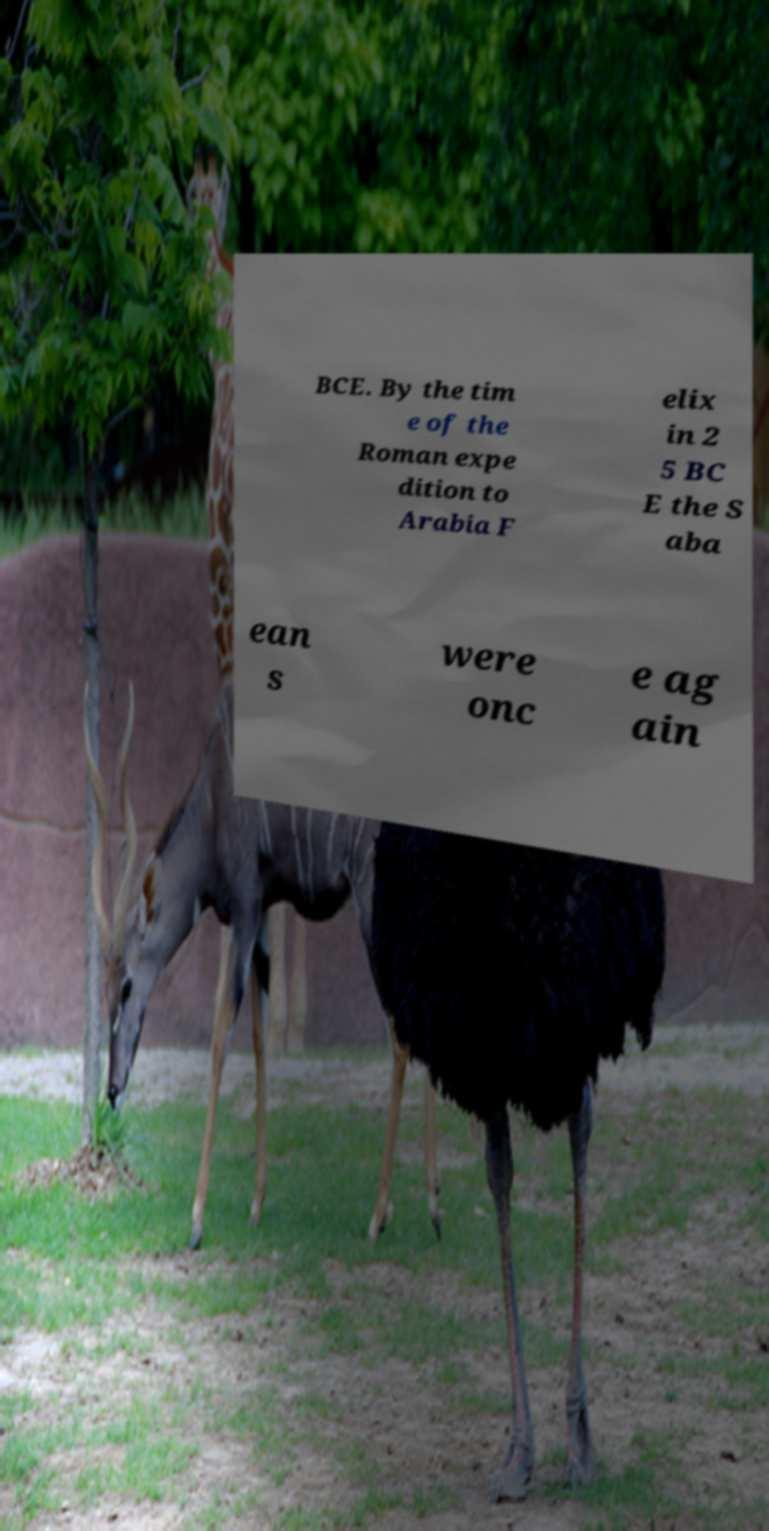Can you read and provide the text displayed in the image?This photo seems to have some interesting text. Can you extract and type it out for me? BCE. By the tim e of the Roman expe dition to Arabia F elix in 2 5 BC E the S aba ean s were onc e ag ain 